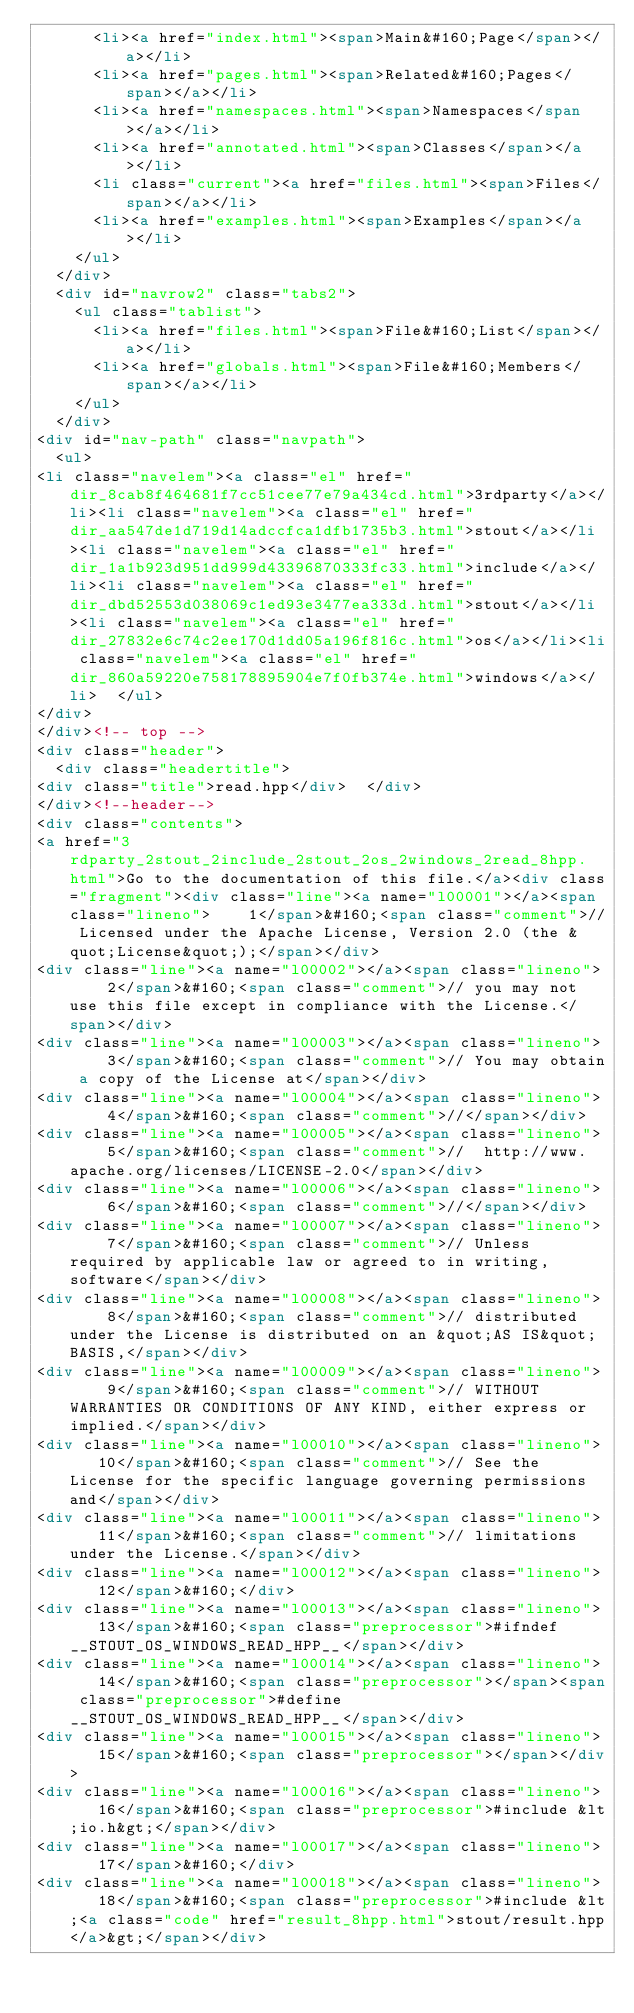<code> <loc_0><loc_0><loc_500><loc_500><_HTML_>      <li><a href="index.html"><span>Main&#160;Page</span></a></li>
      <li><a href="pages.html"><span>Related&#160;Pages</span></a></li>
      <li><a href="namespaces.html"><span>Namespaces</span></a></li>
      <li><a href="annotated.html"><span>Classes</span></a></li>
      <li class="current"><a href="files.html"><span>Files</span></a></li>
      <li><a href="examples.html"><span>Examples</span></a></li>
    </ul>
  </div>
  <div id="navrow2" class="tabs2">
    <ul class="tablist">
      <li><a href="files.html"><span>File&#160;List</span></a></li>
      <li><a href="globals.html"><span>File&#160;Members</span></a></li>
    </ul>
  </div>
<div id="nav-path" class="navpath">
  <ul>
<li class="navelem"><a class="el" href="dir_8cab8f464681f7cc51cee77e79a434cd.html">3rdparty</a></li><li class="navelem"><a class="el" href="dir_aa547de1d719d14adccfca1dfb1735b3.html">stout</a></li><li class="navelem"><a class="el" href="dir_1a1b923d951dd999d43396870333fc33.html">include</a></li><li class="navelem"><a class="el" href="dir_dbd52553d038069c1ed93e3477ea333d.html">stout</a></li><li class="navelem"><a class="el" href="dir_27832e6c74c2ee170d1dd05a196f816c.html">os</a></li><li class="navelem"><a class="el" href="dir_860a59220e758178895904e7f0fb374e.html">windows</a></li>  </ul>
</div>
</div><!-- top -->
<div class="header">
  <div class="headertitle">
<div class="title">read.hpp</div>  </div>
</div><!--header-->
<div class="contents">
<a href="3rdparty_2stout_2include_2stout_2os_2windows_2read_8hpp.html">Go to the documentation of this file.</a><div class="fragment"><div class="line"><a name="l00001"></a><span class="lineno">    1</span>&#160;<span class="comment">// Licensed under the Apache License, Version 2.0 (the &quot;License&quot;);</span></div>
<div class="line"><a name="l00002"></a><span class="lineno">    2</span>&#160;<span class="comment">// you may not use this file except in compliance with the License.</span></div>
<div class="line"><a name="l00003"></a><span class="lineno">    3</span>&#160;<span class="comment">// You may obtain a copy of the License at</span></div>
<div class="line"><a name="l00004"></a><span class="lineno">    4</span>&#160;<span class="comment">//</span></div>
<div class="line"><a name="l00005"></a><span class="lineno">    5</span>&#160;<span class="comment">//  http://www.apache.org/licenses/LICENSE-2.0</span></div>
<div class="line"><a name="l00006"></a><span class="lineno">    6</span>&#160;<span class="comment">//</span></div>
<div class="line"><a name="l00007"></a><span class="lineno">    7</span>&#160;<span class="comment">// Unless required by applicable law or agreed to in writing, software</span></div>
<div class="line"><a name="l00008"></a><span class="lineno">    8</span>&#160;<span class="comment">// distributed under the License is distributed on an &quot;AS IS&quot; BASIS,</span></div>
<div class="line"><a name="l00009"></a><span class="lineno">    9</span>&#160;<span class="comment">// WITHOUT WARRANTIES OR CONDITIONS OF ANY KIND, either express or implied.</span></div>
<div class="line"><a name="l00010"></a><span class="lineno">   10</span>&#160;<span class="comment">// See the License for the specific language governing permissions and</span></div>
<div class="line"><a name="l00011"></a><span class="lineno">   11</span>&#160;<span class="comment">// limitations under the License.</span></div>
<div class="line"><a name="l00012"></a><span class="lineno">   12</span>&#160;</div>
<div class="line"><a name="l00013"></a><span class="lineno">   13</span>&#160;<span class="preprocessor">#ifndef __STOUT_OS_WINDOWS_READ_HPP__</span></div>
<div class="line"><a name="l00014"></a><span class="lineno">   14</span>&#160;<span class="preprocessor"></span><span class="preprocessor">#define __STOUT_OS_WINDOWS_READ_HPP__</span></div>
<div class="line"><a name="l00015"></a><span class="lineno">   15</span>&#160;<span class="preprocessor"></span></div>
<div class="line"><a name="l00016"></a><span class="lineno">   16</span>&#160;<span class="preprocessor">#include &lt;io.h&gt;</span></div>
<div class="line"><a name="l00017"></a><span class="lineno">   17</span>&#160;</div>
<div class="line"><a name="l00018"></a><span class="lineno">   18</span>&#160;<span class="preprocessor">#include &lt;<a class="code" href="result_8hpp.html">stout/result.hpp</a>&gt;</span></div></code> 